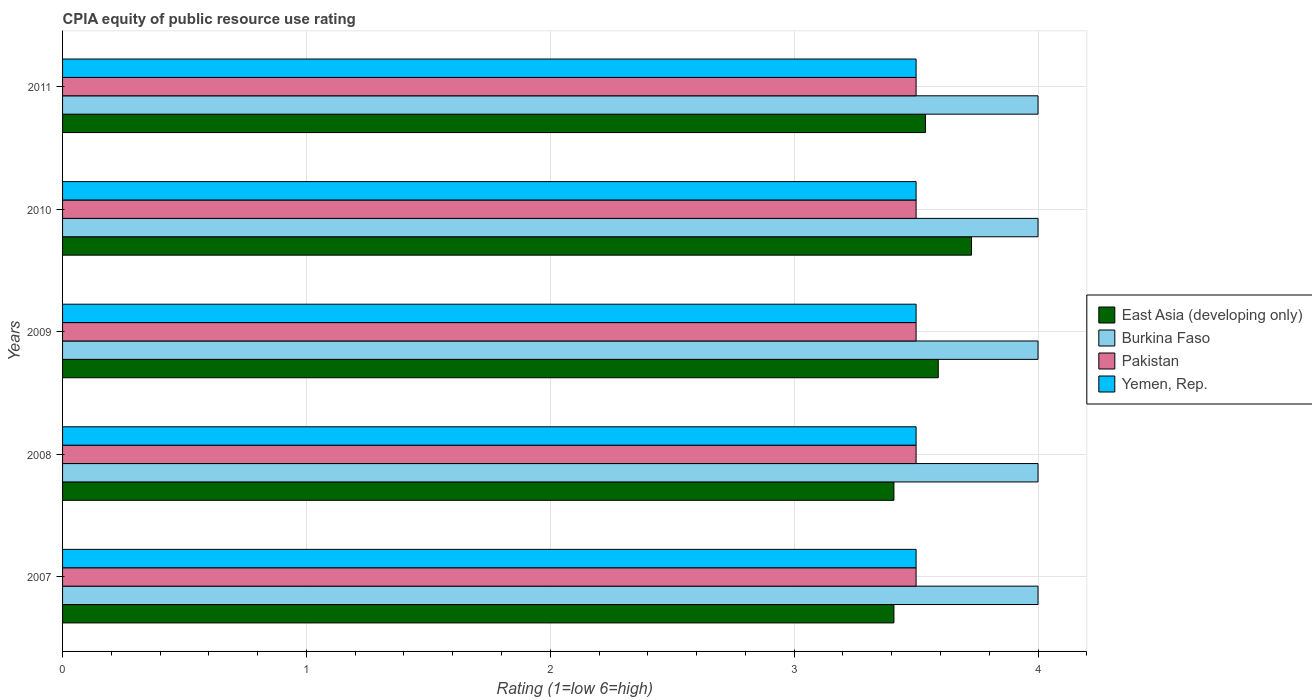How many groups of bars are there?
Offer a terse response. 5. How many bars are there on the 2nd tick from the bottom?
Your answer should be very brief. 4. In how many cases, is the number of bars for a given year not equal to the number of legend labels?
Your answer should be compact. 0. Across all years, what is the maximum CPIA rating in Pakistan?
Offer a terse response. 3.5. Across all years, what is the minimum CPIA rating in Burkina Faso?
Provide a succinct answer. 4. In which year was the CPIA rating in Burkina Faso minimum?
Provide a short and direct response. 2007. What is the total CPIA rating in Burkina Faso in the graph?
Provide a succinct answer. 20. What is the difference between the CPIA rating in East Asia (developing only) in 2008 and that in 2009?
Provide a succinct answer. -0.18. What is the difference between the CPIA rating in East Asia (developing only) in 2008 and the CPIA rating in Pakistan in 2007?
Ensure brevity in your answer.  -0.09. In the year 2010, what is the difference between the CPIA rating in East Asia (developing only) and CPIA rating in Burkina Faso?
Provide a short and direct response. -0.27. In how many years, is the CPIA rating in Burkina Faso greater than the average CPIA rating in Burkina Faso taken over all years?
Ensure brevity in your answer.  0. Is the sum of the CPIA rating in Pakistan in 2007 and 2011 greater than the maximum CPIA rating in Burkina Faso across all years?
Your response must be concise. Yes. What does the 1st bar from the top in 2009 represents?
Your response must be concise. Yemen, Rep. What does the 1st bar from the bottom in 2009 represents?
Keep it short and to the point. East Asia (developing only). How many bars are there?
Offer a terse response. 20. Are all the bars in the graph horizontal?
Your answer should be compact. Yes. Are the values on the major ticks of X-axis written in scientific E-notation?
Keep it short and to the point. No. Does the graph contain any zero values?
Provide a short and direct response. No. Does the graph contain grids?
Provide a succinct answer. Yes. How many legend labels are there?
Make the answer very short. 4. How are the legend labels stacked?
Ensure brevity in your answer.  Vertical. What is the title of the graph?
Ensure brevity in your answer.  CPIA equity of public resource use rating. What is the label or title of the Y-axis?
Offer a very short reply. Years. What is the Rating (1=low 6=high) in East Asia (developing only) in 2007?
Offer a very short reply. 3.41. What is the Rating (1=low 6=high) in Burkina Faso in 2007?
Offer a terse response. 4. What is the Rating (1=low 6=high) in East Asia (developing only) in 2008?
Give a very brief answer. 3.41. What is the Rating (1=low 6=high) of Burkina Faso in 2008?
Your response must be concise. 4. What is the Rating (1=low 6=high) of East Asia (developing only) in 2009?
Give a very brief answer. 3.59. What is the Rating (1=low 6=high) of Pakistan in 2009?
Offer a terse response. 3.5. What is the Rating (1=low 6=high) in Yemen, Rep. in 2009?
Give a very brief answer. 3.5. What is the Rating (1=low 6=high) in East Asia (developing only) in 2010?
Your response must be concise. 3.73. What is the Rating (1=low 6=high) in Yemen, Rep. in 2010?
Ensure brevity in your answer.  3.5. What is the Rating (1=low 6=high) of East Asia (developing only) in 2011?
Make the answer very short. 3.54. What is the Rating (1=low 6=high) of Burkina Faso in 2011?
Give a very brief answer. 4. What is the Rating (1=low 6=high) in Pakistan in 2011?
Keep it short and to the point. 3.5. What is the Rating (1=low 6=high) in Yemen, Rep. in 2011?
Keep it short and to the point. 3.5. Across all years, what is the maximum Rating (1=low 6=high) of East Asia (developing only)?
Offer a very short reply. 3.73. Across all years, what is the maximum Rating (1=low 6=high) of Burkina Faso?
Keep it short and to the point. 4. Across all years, what is the maximum Rating (1=low 6=high) of Pakistan?
Offer a terse response. 3.5. Across all years, what is the maximum Rating (1=low 6=high) of Yemen, Rep.?
Provide a short and direct response. 3.5. Across all years, what is the minimum Rating (1=low 6=high) of East Asia (developing only)?
Your answer should be compact. 3.41. Across all years, what is the minimum Rating (1=low 6=high) of Pakistan?
Make the answer very short. 3.5. Across all years, what is the minimum Rating (1=low 6=high) in Yemen, Rep.?
Your answer should be compact. 3.5. What is the total Rating (1=low 6=high) of East Asia (developing only) in the graph?
Offer a terse response. 17.67. What is the total Rating (1=low 6=high) of Pakistan in the graph?
Your answer should be very brief. 17.5. What is the total Rating (1=low 6=high) of Yemen, Rep. in the graph?
Keep it short and to the point. 17.5. What is the difference between the Rating (1=low 6=high) of Burkina Faso in 2007 and that in 2008?
Make the answer very short. 0. What is the difference between the Rating (1=low 6=high) in Pakistan in 2007 and that in 2008?
Ensure brevity in your answer.  0. What is the difference between the Rating (1=low 6=high) of Yemen, Rep. in 2007 and that in 2008?
Provide a succinct answer. 0. What is the difference between the Rating (1=low 6=high) in East Asia (developing only) in 2007 and that in 2009?
Your answer should be very brief. -0.18. What is the difference between the Rating (1=low 6=high) of Burkina Faso in 2007 and that in 2009?
Give a very brief answer. 0. What is the difference between the Rating (1=low 6=high) in Yemen, Rep. in 2007 and that in 2009?
Offer a very short reply. 0. What is the difference between the Rating (1=low 6=high) in East Asia (developing only) in 2007 and that in 2010?
Your answer should be very brief. -0.32. What is the difference between the Rating (1=low 6=high) in Yemen, Rep. in 2007 and that in 2010?
Offer a terse response. 0. What is the difference between the Rating (1=low 6=high) in East Asia (developing only) in 2007 and that in 2011?
Give a very brief answer. -0.13. What is the difference between the Rating (1=low 6=high) of Pakistan in 2007 and that in 2011?
Ensure brevity in your answer.  0. What is the difference between the Rating (1=low 6=high) of Yemen, Rep. in 2007 and that in 2011?
Keep it short and to the point. 0. What is the difference between the Rating (1=low 6=high) in East Asia (developing only) in 2008 and that in 2009?
Your answer should be very brief. -0.18. What is the difference between the Rating (1=low 6=high) in Burkina Faso in 2008 and that in 2009?
Your response must be concise. 0. What is the difference between the Rating (1=low 6=high) in Pakistan in 2008 and that in 2009?
Provide a succinct answer. 0. What is the difference between the Rating (1=low 6=high) of East Asia (developing only) in 2008 and that in 2010?
Provide a short and direct response. -0.32. What is the difference between the Rating (1=low 6=high) of Burkina Faso in 2008 and that in 2010?
Your response must be concise. 0. What is the difference between the Rating (1=low 6=high) of Yemen, Rep. in 2008 and that in 2010?
Your response must be concise. 0. What is the difference between the Rating (1=low 6=high) of East Asia (developing only) in 2008 and that in 2011?
Provide a succinct answer. -0.13. What is the difference between the Rating (1=low 6=high) in East Asia (developing only) in 2009 and that in 2010?
Keep it short and to the point. -0.14. What is the difference between the Rating (1=low 6=high) in Burkina Faso in 2009 and that in 2010?
Offer a very short reply. 0. What is the difference between the Rating (1=low 6=high) of Pakistan in 2009 and that in 2010?
Make the answer very short. 0. What is the difference between the Rating (1=low 6=high) in East Asia (developing only) in 2009 and that in 2011?
Provide a succinct answer. 0.05. What is the difference between the Rating (1=low 6=high) in Yemen, Rep. in 2009 and that in 2011?
Provide a short and direct response. 0. What is the difference between the Rating (1=low 6=high) of East Asia (developing only) in 2010 and that in 2011?
Make the answer very short. 0.19. What is the difference between the Rating (1=low 6=high) in Burkina Faso in 2010 and that in 2011?
Offer a very short reply. 0. What is the difference between the Rating (1=low 6=high) in Yemen, Rep. in 2010 and that in 2011?
Ensure brevity in your answer.  0. What is the difference between the Rating (1=low 6=high) in East Asia (developing only) in 2007 and the Rating (1=low 6=high) in Burkina Faso in 2008?
Provide a succinct answer. -0.59. What is the difference between the Rating (1=low 6=high) in East Asia (developing only) in 2007 and the Rating (1=low 6=high) in Pakistan in 2008?
Keep it short and to the point. -0.09. What is the difference between the Rating (1=low 6=high) in East Asia (developing only) in 2007 and the Rating (1=low 6=high) in Yemen, Rep. in 2008?
Provide a short and direct response. -0.09. What is the difference between the Rating (1=low 6=high) of Burkina Faso in 2007 and the Rating (1=low 6=high) of Yemen, Rep. in 2008?
Make the answer very short. 0.5. What is the difference between the Rating (1=low 6=high) of East Asia (developing only) in 2007 and the Rating (1=low 6=high) of Burkina Faso in 2009?
Your response must be concise. -0.59. What is the difference between the Rating (1=low 6=high) in East Asia (developing only) in 2007 and the Rating (1=low 6=high) in Pakistan in 2009?
Offer a very short reply. -0.09. What is the difference between the Rating (1=low 6=high) in East Asia (developing only) in 2007 and the Rating (1=low 6=high) in Yemen, Rep. in 2009?
Offer a very short reply. -0.09. What is the difference between the Rating (1=low 6=high) in Burkina Faso in 2007 and the Rating (1=low 6=high) in Pakistan in 2009?
Make the answer very short. 0.5. What is the difference between the Rating (1=low 6=high) of Burkina Faso in 2007 and the Rating (1=low 6=high) of Yemen, Rep. in 2009?
Your answer should be very brief. 0.5. What is the difference between the Rating (1=low 6=high) of Pakistan in 2007 and the Rating (1=low 6=high) of Yemen, Rep. in 2009?
Your response must be concise. 0. What is the difference between the Rating (1=low 6=high) of East Asia (developing only) in 2007 and the Rating (1=low 6=high) of Burkina Faso in 2010?
Keep it short and to the point. -0.59. What is the difference between the Rating (1=low 6=high) in East Asia (developing only) in 2007 and the Rating (1=low 6=high) in Pakistan in 2010?
Ensure brevity in your answer.  -0.09. What is the difference between the Rating (1=low 6=high) of East Asia (developing only) in 2007 and the Rating (1=low 6=high) of Yemen, Rep. in 2010?
Provide a succinct answer. -0.09. What is the difference between the Rating (1=low 6=high) in East Asia (developing only) in 2007 and the Rating (1=low 6=high) in Burkina Faso in 2011?
Provide a short and direct response. -0.59. What is the difference between the Rating (1=low 6=high) of East Asia (developing only) in 2007 and the Rating (1=low 6=high) of Pakistan in 2011?
Keep it short and to the point. -0.09. What is the difference between the Rating (1=low 6=high) of East Asia (developing only) in 2007 and the Rating (1=low 6=high) of Yemen, Rep. in 2011?
Your response must be concise. -0.09. What is the difference between the Rating (1=low 6=high) in East Asia (developing only) in 2008 and the Rating (1=low 6=high) in Burkina Faso in 2009?
Provide a short and direct response. -0.59. What is the difference between the Rating (1=low 6=high) in East Asia (developing only) in 2008 and the Rating (1=low 6=high) in Pakistan in 2009?
Your response must be concise. -0.09. What is the difference between the Rating (1=low 6=high) of East Asia (developing only) in 2008 and the Rating (1=low 6=high) of Yemen, Rep. in 2009?
Make the answer very short. -0.09. What is the difference between the Rating (1=low 6=high) in Burkina Faso in 2008 and the Rating (1=low 6=high) in Pakistan in 2009?
Your answer should be very brief. 0.5. What is the difference between the Rating (1=low 6=high) in Pakistan in 2008 and the Rating (1=low 6=high) in Yemen, Rep. in 2009?
Provide a short and direct response. 0. What is the difference between the Rating (1=low 6=high) of East Asia (developing only) in 2008 and the Rating (1=low 6=high) of Burkina Faso in 2010?
Your response must be concise. -0.59. What is the difference between the Rating (1=low 6=high) in East Asia (developing only) in 2008 and the Rating (1=low 6=high) in Pakistan in 2010?
Your response must be concise. -0.09. What is the difference between the Rating (1=low 6=high) of East Asia (developing only) in 2008 and the Rating (1=low 6=high) of Yemen, Rep. in 2010?
Offer a very short reply. -0.09. What is the difference between the Rating (1=low 6=high) in Burkina Faso in 2008 and the Rating (1=low 6=high) in Pakistan in 2010?
Your answer should be compact. 0.5. What is the difference between the Rating (1=low 6=high) in Burkina Faso in 2008 and the Rating (1=low 6=high) in Yemen, Rep. in 2010?
Keep it short and to the point. 0.5. What is the difference between the Rating (1=low 6=high) of East Asia (developing only) in 2008 and the Rating (1=low 6=high) of Burkina Faso in 2011?
Your answer should be very brief. -0.59. What is the difference between the Rating (1=low 6=high) of East Asia (developing only) in 2008 and the Rating (1=low 6=high) of Pakistan in 2011?
Ensure brevity in your answer.  -0.09. What is the difference between the Rating (1=low 6=high) of East Asia (developing only) in 2008 and the Rating (1=low 6=high) of Yemen, Rep. in 2011?
Your response must be concise. -0.09. What is the difference between the Rating (1=low 6=high) of Burkina Faso in 2008 and the Rating (1=low 6=high) of Yemen, Rep. in 2011?
Give a very brief answer. 0.5. What is the difference between the Rating (1=low 6=high) of Pakistan in 2008 and the Rating (1=low 6=high) of Yemen, Rep. in 2011?
Offer a terse response. 0. What is the difference between the Rating (1=low 6=high) of East Asia (developing only) in 2009 and the Rating (1=low 6=high) of Burkina Faso in 2010?
Provide a short and direct response. -0.41. What is the difference between the Rating (1=low 6=high) of East Asia (developing only) in 2009 and the Rating (1=low 6=high) of Pakistan in 2010?
Your answer should be very brief. 0.09. What is the difference between the Rating (1=low 6=high) in East Asia (developing only) in 2009 and the Rating (1=low 6=high) in Yemen, Rep. in 2010?
Provide a succinct answer. 0.09. What is the difference between the Rating (1=low 6=high) of Burkina Faso in 2009 and the Rating (1=low 6=high) of Yemen, Rep. in 2010?
Your response must be concise. 0.5. What is the difference between the Rating (1=low 6=high) in East Asia (developing only) in 2009 and the Rating (1=low 6=high) in Burkina Faso in 2011?
Keep it short and to the point. -0.41. What is the difference between the Rating (1=low 6=high) of East Asia (developing only) in 2009 and the Rating (1=low 6=high) of Pakistan in 2011?
Keep it short and to the point. 0.09. What is the difference between the Rating (1=low 6=high) in East Asia (developing only) in 2009 and the Rating (1=low 6=high) in Yemen, Rep. in 2011?
Offer a very short reply. 0.09. What is the difference between the Rating (1=low 6=high) in East Asia (developing only) in 2010 and the Rating (1=low 6=high) in Burkina Faso in 2011?
Ensure brevity in your answer.  -0.27. What is the difference between the Rating (1=low 6=high) in East Asia (developing only) in 2010 and the Rating (1=low 6=high) in Pakistan in 2011?
Give a very brief answer. 0.23. What is the difference between the Rating (1=low 6=high) in East Asia (developing only) in 2010 and the Rating (1=low 6=high) in Yemen, Rep. in 2011?
Your answer should be compact. 0.23. What is the average Rating (1=low 6=high) of East Asia (developing only) per year?
Give a very brief answer. 3.54. What is the average Rating (1=low 6=high) of Yemen, Rep. per year?
Ensure brevity in your answer.  3.5. In the year 2007, what is the difference between the Rating (1=low 6=high) of East Asia (developing only) and Rating (1=low 6=high) of Burkina Faso?
Offer a very short reply. -0.59. In the year 2007, what is the difference between the Rating (1=low 6=high) of East Asia (developing only) and Rating (1=low 6=high) of Pakistan?
Your response must be concise. -0.09. In the year 2007, what is the difference between the Rating (1=low 6=high) of East Asia (developing only) and Rating (1=low 6=high) of Yemen, Rep.?
Ensure brevity in your answer.  -0.09. In the year 2007, what is the difference between the Rating (1=low 6=high) of Pakistan and Rating (1=low 6=high) of Yemen, Rep.?
Keep it short and to the point. 0. In the year 2008, what is the difference between the Rating (1=low 6=high) of East Asia (developing only) and Rating (1=low 6=high) of Burkina Faso?
Your response must be concise. -0.59. In the year 2008, what is the difference between the Rating (1=low 6=high) in East Asia (developing only) and Rating (1=low 6=high) in Pakistan?
Provide a succinct answer. -0.09. In the year 2008, what is the difference between the Rating (1=low 6=high) of East Asia (developing only) and Rating (1=low 6=high) of Yemen, Rep.?
Your response must be concise. -0.09. In the year 2009, what is the difference between the Rating (1=low 6=high) in East Asia (developing only) and Rating (1=low 6=high) in Burkina Faso?
Give a very brief answer. -0.41. In the year 2009, what is the difference between the Rating (1=low 6=high) in East Asia (developing only) and Rating (1=low 6=high) in Pakistan?
Make the answer very short. 0.09. In the year 2009, what is the difference between the Rating (1=low 6=high) of East Asia (developing only) and Rating (1=low 6=high) of Yemen, Rep.?
Your answer should be compact. 0.09. In the year 2009, what is the difference between the Rating (1=low 6=high) of Burkina Faso and Rating (1=low 6=high) of Pakistan?
Your answer should be compact. 0.5. In the year 2009, what is the difference between the Rating (1=low 6=high) of Burkina Faso and Rating (1=low 6=high) of Yemen, Rep.?
Offer a terse response. 0.5. In the year 2010, what is the difference between the Rating (1=low 6=high) of East Asia (developing only) and Rating (1=low 6=high) of Burkina Faso?
Provide a succinct answer. -0.27. In the year 2010, what is the difference between the Rating (1=low 6=high) of East Asia (developing only) and Rating (1=low 6=high) of Pakistan?
Make the answer very short. 0.23. In the year 2010, what is the difference between the Rating (1=low 6=high) in East Asia (developing only) and Rating (1=low 6=high) in Yemen, Rep.?
Offer a very short reply. 0.23. In the year 2010, what is the difference between the Rating (1=low 6=high) in Burkina Faso and Rating (1=low 6=high) in Pakistan?
Make the answer very short. 0.5. In the year 2010, what is the difference between the Rating (1=low 6=high) in Burkina Faso and Rating (1=low 6=high) in Yemen, Rep.?
Provide a short and direct response. 0.5. In the year 2010, what is the difference between the Rating (1=low 6=high) in Pakistan and Rating (1=low 6=high) in Yemen, Rep.?
Your response must be concise. 0. In the year 2011, what is the difference between the Rating (1=low 6=high) of East Asia (developing only) and Rating (1=low 6=high) of Burkina Faso?
Provide a short and direct response. -0.46. In the year 2011, what is the difference between the Rating (1=low 6=high) in East Asia (developing only) and Rating (1=low 6=high) in Pakistan?
Your answer should be compact. 0.04. In the year 2011, what is the difference between the Rating (1=low 6=high) in East Asia (developing only) and Rating (1=low 6=high) in Yemen, Rep.?
Offer a very short reply. 0.04. In the year 2011, what is the difference between the Rating (1=low 6=high) in Burkina Faso and Rating (1=low 6=high) in Yemen, Rep.?
Offer a very short reply. 0.5. What is the ratio of the Rating (1=low 6=high) of East Asia (developing only) in 2007 to that in 2008?
Your answer should be compact. 1. What is the ratio of the Rating (1=low 6=high) in Yemen, Rep. in 2007 to that in 2008?
Make the answer very short. 1. What is the ratio of the Rating (1=low 6=high) of East Asia (developing only) in 2007 to that in 2009?
Give a very brief answer. 0.95. What is the ratio of the Rating (1=low 6=high) of Burkina Faso in 2007 to that in 2009?
Provide a short and direct response. 1. What is the ratio of the Rating (1=low 6=high) in Pakistan in 2007 to that in 2009?
Your answer should be compact. 1. What is the ratio of the Rating (1=low 6=high) in Yemen, Rep. in 2007 to that in 2009?
Provide a succinct answer. 1. What is the ratio of the Rating (1=low 6=high) of East Asia (developing only) in 2007 to that in 2010?
Provide a short and direct response. 0.91. What is the ratio of the Rating (1=low 6=high) in Burkina Faso in 2007 to that in 2010?
Your response must be concise. 1. What is the ratio of the Rating (1=low 6=high) in Pakistan in 2007 to that in 2010?
Your answer should be compact. 1. What is the ratio of the Rating (1=low 6=high) in Yemen, Rep. in 2007 to that in 2010?
Give a very brief answer. 1. What is the ratio of the Rating (1=low 6=high) of East Asia (developing only) in 2007 to that in 2011?
Provide a short and direct response. 0.96. What is the ratio of the Rating (1=low 6=high) in East Asia (developing only) in 2008 to that in 2009?
Your answer should be compact. 0.95. What is the ratio of the Rating (1=low 6=high) in Burkina Faso in 2008 to that in 2009?
Provide a short and direct response. 1. What is the ratio of the Rating (1=low 6=high) in Pakistan in 2008 to that in 2009?
Ensure brevity in your answer.  1. What is the ratio of the Rating (1=low 6=high) of East Asia (developing only) in 2008 to that in 2010?
Provide a short and direct response. 0.91. What is the ratio of the Rating (1=low 6=high) of Burkina Faso in 2008 to that in 2010?
Give a very brief answer. 1. What is the ratio of the Rating (1=low 6=high) of Pakistan in 2008 to that in 2010?
Provide a short and direct response. 1. What is the ratio of the Rating (1=low 6=high) of Yemen, Rep. in 2008 to that in 2010?
Keep it short and to the point. 1. What is the ratio of the Rating (1=low 6=high) of East Asia (developing only) in 2008 to that in 2011?
Give a very brief answer. 0.96. What is the ratio of the Rating (1=low 6=high) in Yemen, Rep. in 2008 to that in 2011?
Offer a terse response. 1. What is the ratio of the Rating (1=low 6=high) of East Asia (developing only) in 2009 to that in 2010?
Provide a short and direct response. 0.96. What is the ratio of the Rating (1=low 6=high) of Burkina Faso in 2009 to that in 2010?
Provide a succinct answer. 1. What is the ratio of the Rating (1=low 6=high) in Pakistan in 2009 to that in 2010?
Offer a terse response. 1. What is the ratio of the Rating (1=low 6=high) of Yemen, Rep. in 2009 to that in 2010?
Your response must be concise. 1. What is the ratio of the Rating (1=low 6=high) in East Asia (developing only) in 2009 to that in 2011?
Ensure brevity in your answer.  1.01. What is the ratio of the Rating (1=low 6=high) in Yemen, Rep. in 2009 to that in 2011?
Your answer should be very brief. 1. What is the ratio of the Rating (1=low 6=high) of East Asia (developing only) in 2010 to that in 2011?
Offer a terse response. 1.05. What is the ratio of the Rating (1=low 6=high) of Burkina Faso in 2010 to that in 2011?
Your answer should be very brief. 1. What is the ratio of the Rating (1=low 6=high) in Pakistan in 2010 to that in 2011?
Provide a short and direct response. 1. What is the difference between the highest and the second highest Rating (1=low 6=high) in East Asia (developing only)?
Your answer should be very brief. 0.14. What is the difference between the highest and the second highest Rating (1=low 6=high) of Pakistan?
Provide a short and direct response. 0. What is the difference between the highest and the lowest Rating (1=low 6=high) of East Asia (developing only)?
Your answer should be compact. 0.32. What is the difference between the highest and the lowest Rating (1=low 6=high) in Pakistan?
Provide a short and direct response. 0. What is the difference between the highest and the lowest Rating (1=low 6=high) of Yemen, Rep.?
Your answer should be compact. 0. 